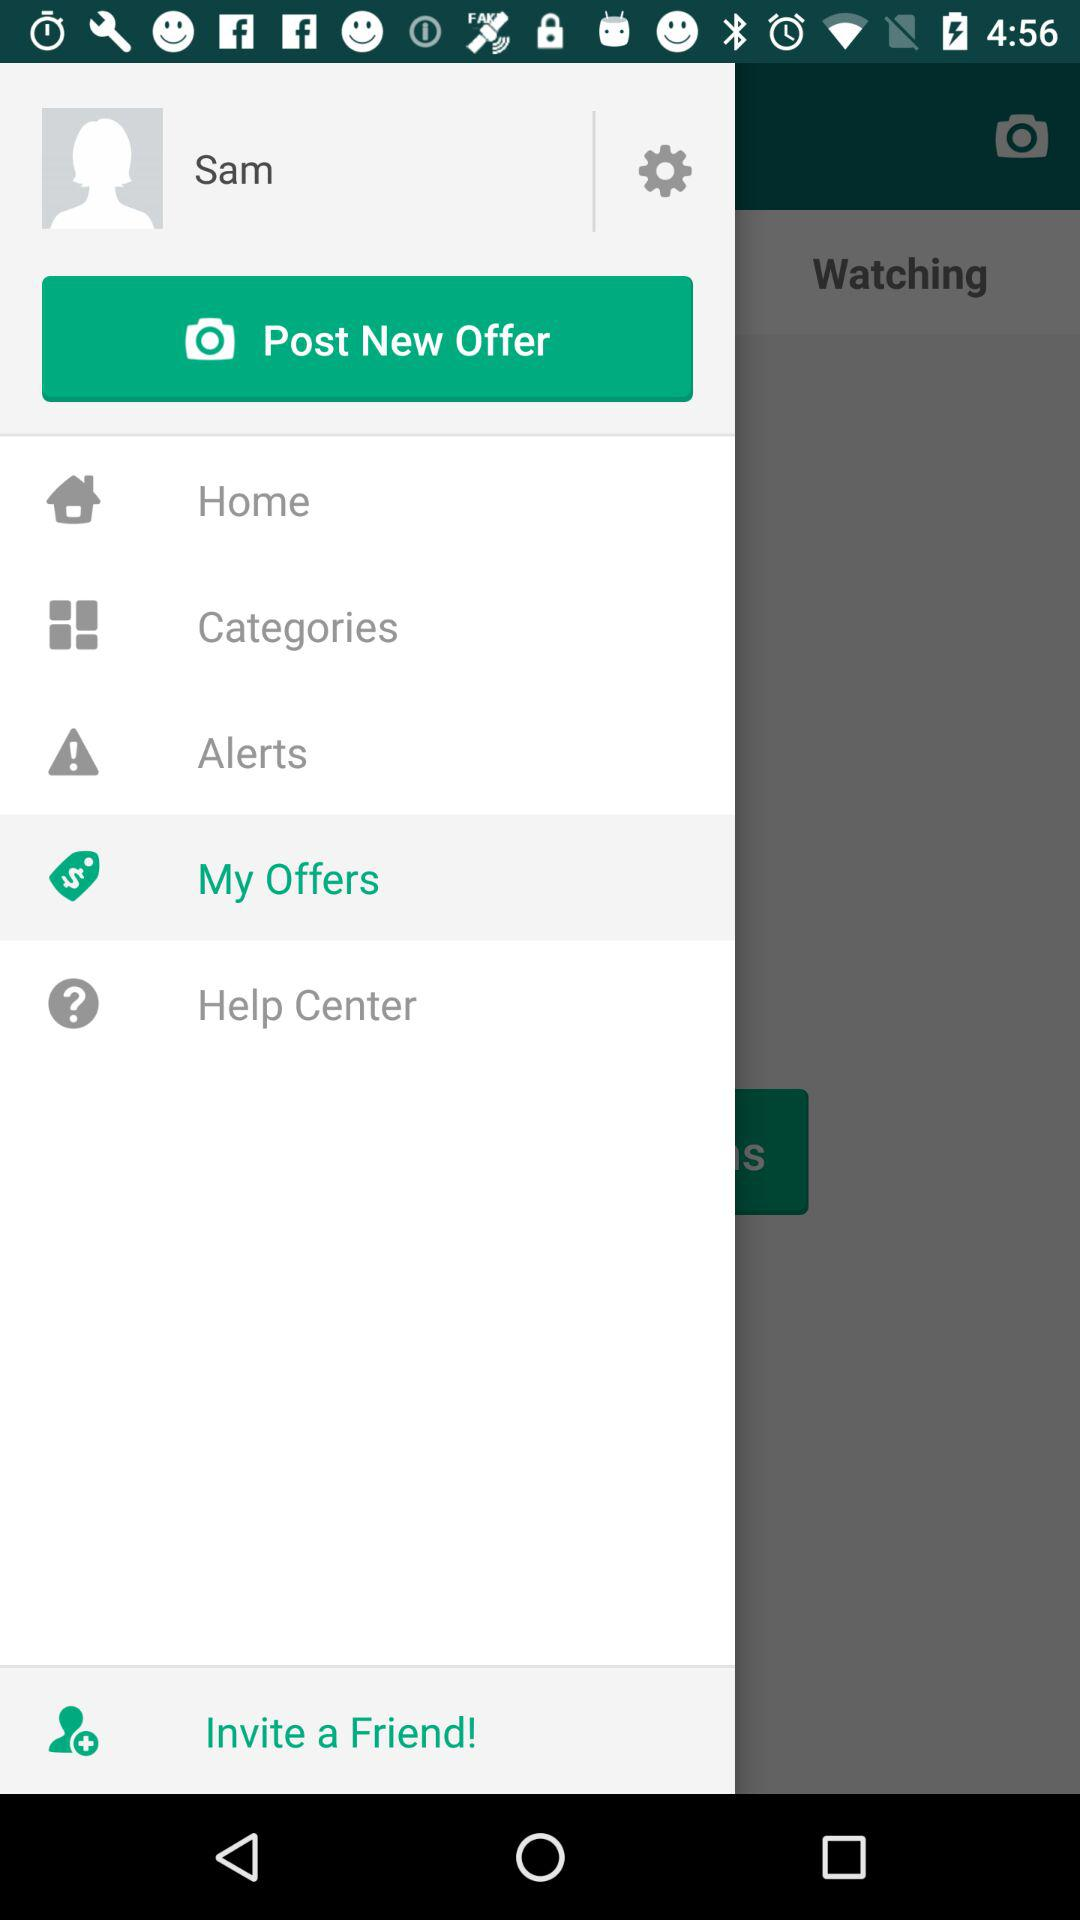What is the user name? The user name is Sam. 